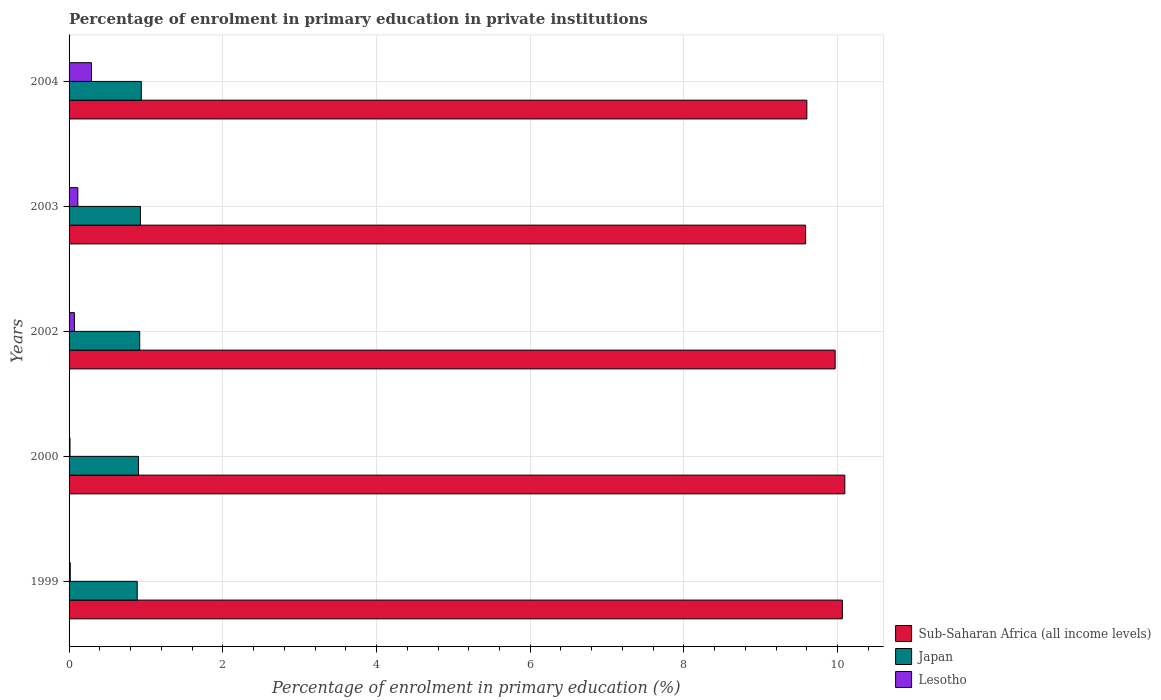How many different coloured bars are there?
Your response must be concise. 3. How many groups of bars are there?
Offer a very short reply. 5. How many bars are there on the 1st tick from the top?
Ensure brevity in your answer.  3. What is the label of the 4th group of bars from the top?
Ensure brevity in your answer.  2000. In how many cases, is the number of bars for a given year not equal to the number of legend labels?
Ensure brevity in your answer.  0. What is the percentage of enrolment in primary education in Sub-Saharan Africa (all income levels) in 1999?
Your answer should be compact. 10.06. Across all years, what is the maximum percentage of enrolment in primary education in Lesotho?
Provide a short and direct response. 0.29. Across all years, what is the minimum percentage of enrolment in primary education in Sub-Saharan Africa (all income levels)?
Offer a very short reply. 9.58. In which year was the percentage of enrolment in primary education in Lesotho maximum?
Your response must be concise. 2004. What is the total percentage of enrolment in primary education in Sub-Saharan Africa (all income levels) in the graph?
Ensure brevity in your answer.  49.3. What is the difference between the percentage of enrolment in primary education in Japan in 2000 and that in 2004?
Provide a succinct answer. -0.04. What is the difference between the percentage of enrolment in primary education in Japan in 2004 and the percentage of enrolment in primary education in Lesotho in 2000?
Keep it short and to the point. 0.93. What is the average percentage of enrolment in primary education in Lesotho per year?
Provide a short and direct response. 0.1. In the year 1999, what is the difference between the percentage of enrolment in primary education in Japan and percentage of enrolment in primary education in Lesotho?
Offer a very short reply. 0.87. What is the ratio of the percentage of enrolment in primary education in Japan in 2000 to that in 2002?
Offer a terse response. 0.98. Is the difference between the percentage of enrolment in primary education in Japan in 2000 and 2003 greater than the difference between the percentage of enrolment in primary education in Lesotho in 2000 and 2003?
Keep it short and to the point. Yes. What is the difference between the highest and the second highest percentage of enrolment in primary education in Sub-Saharan Africa (all income levels)?
Your answer should be compact. 0.03. What is the difference between the highest and the lowest percentage of enrolment in primary education in Sub-Saharan Africa (all income levels)?
Keep it short and to the point. 0.51. In how many years, is the percentage of enrolment in primary education in Japan greater than the average percentage of enrolment in primary education in Japan taken over all years?
Your answer should be compact. 3. Is the sum of the percentage of enrolment in primary education in Japan in 2002 and 2003 greater than the maximum percentage of enrolment in primary education in Sub-Saharan Africa (all income levels) across all years?
Offer a very short reply. No. What does the 1st bar from the bottom in 1999 represents?
Provide a succinct answer. Sub-Saharan Africa (all income levels). Is it the case that in every year, the sum of the percentage of enrolment in primary education in Japan and percentage of enrolment in primary education in Lesotho is greater than the percentage of enrolment in primary education in Sub-Saharan Africa (all income levels)?
Keep it short and to the point. No. How many bars are there?
Keep it short and to the point. 15. What is the difference between two consecutive major ticks on the X-axis?
Make the answer very short. 2. Are the values on the major ticks of X-axis written in scientific E-notation?
Your answer should be very brief. No. Does the graph contain any zero values?
Give a very brief answer. No. Where does the legend appear in the graph?
Your response must be concise. Bottom right. How many legend labels are there?
Offer a very short reply. 3. What is the title of the graph?
Your answer should be very brief. Percentage of enrolment in primary education in private institutions. Does "Micronesia" appear as one of the legend labels in the graph?
Your response must be concise. No. What is the label or title of the X-axis?
Offer a very short reply. Percentage of enrolment in primary education (%). What is the Percentage of enrolment in primary education (%) of Sub-Saharan Africa (all income levels) in 1999?
Your response must be concise. 10.06. What is the Percentage of enrolment in primary education (%) in Japan in 1999?
Ensure brevity in your answer.  0.89. What is the Percentage of enrolment in primary education (%) in Lesotho in 1999?
Provide a succinct answer. 0.02. What is the Percentage of enrolment in primary education (%) of Sub-Saharan Africa (all income levels) in 2000?
Keep it short and to the point. 10.09. What is the Percentage of enrolment in primary education (%) in Japan in 2000?
Your answer should be compact. 0.9. What is the Percentage of enrolment in primary education (%) of Lesotho in 2000?
Keep it short and to the point. 0.01. What is the Percentage of enrolment in primary education (%) in Sub-Saharan Africa (all income levels) in 2002?
Ensure brevity in your answer.  9.97. What is the Percentage of enrolment in primary education (%) in Japan in 2002?
Provide a short and direct response. 0.92. What is the Percentage of enrolment in primary education (%) of Lesotho in 2002?
Give a very brief answer. 0.07. What is the Percentage of enrolment in primary education (%) of Sub-Saharan Africa (all income levels) in 2003?
Your answer should be very brief. 9.58. What is the Percentage of enrolment in primary education (%) in Japan in 2003?
Your answer should be compact. 0.93. What is the Percentage of enrolment in primary education (%) of Lesotho in 2003?
Your answer should be very brief. 0.11. What is the Percentage of enrolment in primary education (%) of Sub-Saharan Africa (all income levels) in 2004?
Provide a succinct answer. 9.6. What is the Percentage of enrolment in primary education (%) in Japan in 2004?
Your response must be concise. 0.94. What is the Percentage of enrolment in primary education (%) in Lesotho in 2004?
Give a very brief answer. 0.29. Across all years, what is the maximum Percentage of enrolment in primary education (%) in Sub-Saharan Africa (all income levels)?
Ensure brevity in your answer.  10.09. Across all years, what is the maximum Percentage of enrolment in primary education (%) in Japan?
Your answer should be compact. 0.94. Across all years, what is the maximum Percentage of enrolment in primary education (%) of Lesotho?
Ensure brevity in your answer.  0.29. Across all years, what is the minimum Percentage of enrolment in primary education (%) of Sub-Saharan Africa (all income levels)?
Your answer should be very brief. 9.58. Across all years, what is the minimum Percentage of enrolment in primary education (%) in Japan?
Provide a short and direct response. 0.89. Across all years, what is the minimum Percentage of enrolment in primary education (%) in Lesotho?
Your answer should be compact. 0.01. What is the total Percentage of enrolment in primary education (%) in Sub-Saharan Africa (all income levels) in the graph?
Your response must be concise. 49.3. What is the total Percentage of enrolment in primary education (%) in Japan in the graph?
Provide a short and direct response. 4.58. What is the total Percentage of enrolment in primary education (%) of Lesotho in the graph?
Offer a terse response. 0.5. What is the difference between the Percentage of enrolment in primary education (%) in Sub-Saharan Africa (all income levels) in 1999 and that in 2000?
Offer a terse response. -0.03. What is the difference between the Percentage of enrolment in primary education (%) in Japan in 1999 and that in 2000?
Offer a very short reply. -0.02. What is the difference between the Percentage of enrolment in primary education (%) in Lesotho in 1999 and that in 2000?
Provide a short and direct response. 0. What is the difference between the Percentage of enrolment in primary education (%) in Sub-Saharan Africa (all income levels) in 1999 and that in 2002?
Offer a terse response. 0.09. What is the difference between the Percentage of enrolment in primary education (%) in Japan in 1999 and that in 2002?
Provide a short and direct response. -0.03. What is the difference between the Percentage of enrolment in primary education (%) in Lesotho in 1999 and that in 2002?
Make the answer very short. -0.05. What is the difference between the Percentage of enrolment in primary education (%) in Sub-Saharan Africa (all income levels) in 1999 and that in 2003?
Offer a terse response. 0.48. What is the difference between the Percentage of enrolment in primary education (%) in Japan in 1999 and that in 2003?
Offer a terse response. -0.04. What is the difference between the Percentage of enrolment in primary education (%) of Lesotho in 1999 and that in 2003?
Provide a succinct answer. -0.1. What is the difference between the Percentage of enrolment in primary education (%) of Sub-Saharan Africa (all income levels) in 1999 and that in 2004?
Ensure brevity in your answer.  0.46. What is the difference between the Percentage of enrolment in primary education (%) in Japan in 1999 and that in 2004?
Keep it short and to the point. -0.05. What is the difference between the Percentage of enrolment in primary education (%) in Lesotho in 1999 and that in 2004?
Provide a succinct answer. -0.28. What is the difference between the Percentage of enrolment in primary education (%) of Sub-Saharan Africa (all income levels) in 2000 and that in 2002?
Give a very brief answer. 0.13. What is the difference between the Percentage of enrolment in primary education (%) in Japan in 2000 and that in 2002?
Provide a short and direct response. -0.02. What is the difference between the Percentage of enrolment in primary education (%) in Lesotho in 2000 and that in 2002?
Your response must be concise. -0.06. What is the difference between the Percentage of enrolment in primary education (%) in Sub-Saharan Africa (all income levels) in 2000 and that in 2003?
Your answer should be compact. 0.51. What is the difference between the Percentage of enrolment in primary education (%) in Japan in 2000 and that in 2003?
Your response must be concise. -0.02. What is the difference between the Percentage of enrolment in primary education (%) of Lesotho in 2000 and that in 2003?
Keep it short and to the point. -0.1. What is the difference between the Percentage of enrolment in primary education (%) of Sub-Saharan Africa (all income levels) in 2000 and that in 2004?
Provide a succinct answer. 0.49. What is the difference between the Percentage of enrolment in primary education (%) of Japan in 2000 and that in 2004?
Offer a terse response. -0.04. What is the difference between the Percentage of enrolment in primary education (%) of Lesotho in 2000 and that in 2004?
Your answer should be very brief. -0.28. What is the difference between the Percentage of enrolment in primary education (%) in Sub-Saharan Africa (all income levels) in 2002 and that in 2003?
Give a very brief answer. 0.38. What is the difference between the Percentage of enrolment in primary education (%) in Japan in 2002 and that in 2003?
Provide a short and direct response. -0.01. What is the difference between the Percentage of enrolment in primary education (%) in Lesotho in 2002 and that in 2003?
Keep it short and to the point. -0.04. What is the difference between the Percentage of enrolment in primary education (%) in Sub-Saharan Africa (all income levels) in 2002 and that in 2004?
Make the answer very short. 0.37. What is the difference between the Percentage of enrolment in primary education (%) in Japan in 2002 and that in 2004?
Ensure brevity in your answer.  -0.02. What is the difference between the Percentage of enrolment in primary education (%) of Lesotho in 2002 and that in 2004?
Your answer should be compact. -0.22. What is the difference between the Percentage of enrolment in primary education (%) in Sub-Saharan Africa (all income levels) in 2003 and that in 2004?
Make the answer very short. -0.02. What is the difference between the Percentage of enrolment in primary education (%) of Japan in 2003 and that in 2004?
Offer a very short reply. -0.01. What is the difference between the Percentage of enrolment in primary education (%) of Lesotho in 2003 and that in 2004?
Keep it short and to the point. -0.18. What is the difference between the Percentage of enrolment in primary education (%) in Sub-Saharan Africa (all income levels) in 1999 and the Percentage of enrolment in primary education (%) in Japan in 2000?
Keep it short and to the point. 9.16. What is the difference between the Percentage of enrolment in primary education (%) of Sub-Saharan Africa (all income levels) in 1999 and the Percentage of enrolment in primary education (%) of Lesotho in 2000?
Keep it short and to the point. 10.05. What is the difference between the Percentage of enrolment in primary education (%) of Japan in 1999 and the Percentage of enrolment in primary education (%) of Lesotho in 2000?
Your answer should be compact. 0.87. What is the difference between the Percentage of enrolment in primary education (%) in Sub-Saharan Africa (all income levels) in 1999 and the Percentage of enrolment in primary education (%) in Japan in 2002?
Your answer should be very brief. 9.14. What is the difference between the Percentage of enrolment in primary education (%) of Sub-Saharan Africa (all income levels) in 1999 and the Percentage of enrolment in primary education (%) of Lesotho in 2002?
Give a very brief answer. 9.99. What is the difference between the Percentage of enrolment in primary education (%) of Japan in 1999 and the Percentage of enrolment in primary education (%) of Lesotho in 2002?
Offer a very short reply. 0.82. What is the difference between the Percentage of enrolment in primary education (%) in Sub-Saharan Africa (all income levels) in 1999 and the Percentage of enrolment in primary education (%) in Japan in 2003?
Ensure brevity in your answer.  9.13. What is the difference between the Percentage of enrolment in primary education (%) of Sub-Saharan Africa (all income levels) in 1999 and the Percentage of enrolment in primary education (%) of Lesotho in 2003?
Make the answer very short. 9.95. What is the difference between the Percentage of enrolment in primary education (%) of Japan in 1999 and the Percentage of enrolment in primary education (%) of Lesotho in 2003?
Provide a short and direct response. 0.77. What is the difference between the Percentage of enrolment in primary education (%) of Sub-Saharan Africa (all income levels) in 1999 and the Percentage of enrolment in primary education (%) of Japan in 2004?
Ensure brevity in your answer.  9.12. What is the difference between the Percentage of enrolment in primary education (%) of Sub-Saharan Africa (all income levels) in 1999 and the Percentage of enrolment in primary education (%) of Lesotho in 2004?
Make the answer very short. 9.77. What is the difference between the Percentage of enrolment in primary education (%) in Japan in 1999 and the Percentage of enrolment in primary education (%) in Lesotho in 2004?
Give a very brief answer. 0.6. What is the difference between the Percentage of enrolment in primary education (%) in Sub-Saharan Africa (all income levels) in 2000 and the Percentage of enrolment in primary education (%) in Japan in 2002?
Offer a terse response. 9.17. What is the difference between the Percentage of enrolment in primary education (%) of Sub-Saharan Africa (all income levels) in 2000 and the Percentage of enrolment in primary education (%) of Lesotho in 2002?
Offer a terse response. 10.02. What is the difference between the Percentage of enrolment in primary education (%) in Japan in 2000 and the Percentage of enrolment in primary education (%) in Lesotho in 2002?
Your response must be concise. 0.83. What is the difference between the Percentage of enrolment in primary education (%) in Sub-Saharan Africa (all income levels) in 2000 and the Percentage of enrolment in primary education (%) in Japan in 2003?
Your answer should be compact. 9.16. What is the difference between the Percentage of enrolment in primary education (%) of Sub-Saharan Africa (all income levels) in 2000 and the Percentage of enrolment in primary education (%) of Lesotho in 2003?
Provide a succinct answer. 9.98. What is the difference between the Percentage of enrolment in primary education (%) in Japan in 2000 and the Percentage of enrolment in primary education (%) in Lesotho in 2003?
Ensure brevity in your answer.  0.79. What is the difference between the Percentage of enrolment in primary education (%) in Sub-Saharan Africa (all income levels) in 2000 and the Percentage of enrolment in primary education (%) in Japan in 2004?
Give a very brief answer. 9.15. What is the difference between the Percentage of enrolment in primary education (%) of Sub-Saharan Africa (all income levels) in 2000 and the Percentage of enrolment in primary education (%) of Lesotho in 2004?
Your answer should be very brief. 9.8. What is the difference between the Percentage of enrolment in primary education (%) of Japan in 2000 and the Percentage of enrolment in primary education (%) of Lesotho in 2004?
Your answer should be compact. 0.61. What is the difference between the Percentage of enrolment in primary education (%) in Sub-Saharan Africa (all income levels) in 2002 and the Percentage of enrolment in primary education (%) in Japan in 2003?
Make the answer very short. 9.04. What is the difference between the Percentage of enrolment in primary education (%) in Sub-Saharan Africa (all income levels) in 2002 and the Percentage of enrolment in primary education (%) in Lesotho in 2003?
Keep it short and to the point. 9.85. What is the difference between the Percentage of enrolment in primary education (%) of Japan in 2002 and the Percentage of enrolment in primary education (%) of Lesotho in 2003?
Offer a terse response. 0.81. What is the difference between the Percentage of enrolment in primary education (%) in Sub-Saharan Africa (all income levels) in 2002 and the Percentage of enrolment in primary education (%) in Japan in 2004?
Provide a short and direct response. 9.03. What is the difference between the Percentage of enrolment in primary education (%) in Sub-Saharan Africa (all income levels) in 2002 and the Percentage of enrolment in primary education (%) in Lesotho in 2004?
Offer a very short reply. 9.68. What is the difference between the Percentage of enrolment in primary education (%) of Japan in 2002 and the Percentage of enrolment in primary education (%) of Lesotho in 2004?
Provide a succinct answer. 0.63. What is the difference between the Percentage of enrolment in primary education (%) in Sub-Saharan Africa (all income levels) in 2003 and the Percentage of enrolment in primary education (%) in Japan in 2004?
Ensure brevity in your answer.  8.64. What is the difference between the Percentage of enrolment in primary education (%) in Sub-Saharan Africa (all income levels) in 2003 and the Percentage of enrolment in primary education (%) in Lesotho in 2004?
Provide a short and direct response. 9.29. What is the difference between the Percentage of enrolment in primary education (%) in Japan in 2003 and the Percentage of enrolment in primary education (%) in Lesotho in 2004?
Provide a short and direct response. 0.64. What is the average Percentage of enrolment in primary education (%) of Sub-Saharan Africa (all income levels) per year?
Keep it short and to the point. 9.86. What is the average Percentage of enrolment in primary education (%) in Japan per year?
Your answer should be compact. 0.92. What is the average Percentage of enrolment in primary education (%) of Lesotho per year?
Your response must be concise. 0.1. In the year 1999, what is the difference between the Percentage of enrolment in primary education (%) of Sub-Saharan Africa (all income levels) and Percentage of enrolment in primary education (%) of Japan?
Provide a short and direct response. 9.17. In the year 1999, what is the difference between the Percentage of enrolment in primary education (%) of Sub-Saharan Africa (all income levels) and Percentage of enrolment in primary education (%) of Lesotho?
Your answer should be very brief. 10.05. In the year 1999, what is the difference between the Percentage of enrolment in primary education (%) in Japan and Percentage of enrolment in primary education (%) in Lesotho?
Your answer should be very brief. 0.87. In the year 2000, what is the difference between the Percentage of enrolment in primary education (%) of Sub-Saharan Africa (all income levels) and Percentage of enrolment in primary education (%) of Japan?
Offer a very short reply. 9.19. In the year 2000, what is the difference between the Percentage of enrolment in primary education (%) in Sub-Saharan Africa (all income levels) and Percentage of enrolment in primary education (%) in Lesotho?
Ensure brevity in your answer.  10.08. In the year 2000, what is the difference between the Percentage of enrolment in primary education (%) of Japan and Percentage of enrolment in primary education (%) of Lesotho?
Provide a short and direct response. 0.89. In the year 2002, what is the difference between the Percentage of enrolment in primary education (%) in Sub-Saharan Africa (all income levels) and Percentage of enrolment in primary education (%) in Japan?
Provide a succinct answer. 9.05. In the year 2002, what is the difference between the Percentage of enrolment in primary education (%) of Sub-Saharan Africa (all income levels) and Percentage of enrolment in primary education (%) of Lesotho?
Provide a short and direct response. 9.9. In the year 2002, what is the difference between the Percentage of enrolment in primary education (%) of Japan and Percentage of enrolment in primary education (%) of Lesotho?
Your answer should be compact. 0.85. In the year 2003, what is the difference between the Percentage of enrolment in primary education (%) in Sub-Saharan Africa (all income levels) and Percentage of enrolment in primary education (%) in Japan?
Give a very brief answer. 8.65. In the year 2003, what is the difference between the Percentage of enrolment in primary education (%) in Sub-Saharan Africa (all income levels) and Percentage of enrolment in primary education (%) in Lesotho?
Your answer should be compact. 9.47. In the year 2003, what is the difference between the Percentage of enrolment in primary education (%) of Japan and Percentage of enrolment in primary education (%) of Lesotho?
Offer a terse response. 0.81. In the year 2004, what is the difference between the Percentage of enrolment in primary education (%) in Sub-Saharan Africa (all income levels) and Percentage of enrolment in primary education (%) in Japan?
Your answer should be compact. 8.66. In the year 2004, what is the difference between the Percentage of enrolment in primary education (%) in Sub-Saharan Africa (all income levels) and Percentage of enrolment in primary education (%) in Lesotho?
Provide a succinct answer. 9.31. In the year 2004, what is the difference between the Percentage of enrolment in primary education (%) of Japan and Percentage of enrolment in primary education (%) of Lesotho?
Give a very brief answer. 0.65. What is the ratio of the Percentage of enrolment in primary education (%) in Sub-Saharan Africa (all income levels) in 1999 to that in 2000?
Offer a very short reply. 1. What is the ratio of the Percentage of enrolment in primary education (%) of Lesotho in 1999 to that in 2000?
Give a very brief answer. 1.28. What is the ratio of the Percentage of enrolment in primary education (%) in Sub-Saharan Africa (all income levels) in 1999 to that in 2002?
Give a very brief answer. 1.01. What is the ratio of the Percentage of enrolment in primary education (%) of Japan in 1999 to that in 2002?
Make the answer very short. 0.96. What is the ratio of the Percentage of enrolment in primary education (%) in Lesotho in 1999 to that in 2002?
Your answer should be very brief. 0.22. What is the ratio of the Percentage of enrolment in primary education (%) in Sub-Saharan Africa (all income levels) in 1999 to that in 2003?
Ensure brevity in your answer.  1.05. What is the ratio of the Percentage of enrolment in primary education (%) in Japan in 1999 to that in 2003?
Keep it short and to the point. 0.95. What is the ratio of the Percentage of enrolment in primary education (%) of Lesotho in 1999 to that in 2003?
Provide a short and direct response. 0.14. What is the ratio of the Percentage of enrolment in primary education (%) of Sub-Saharan Africa (all income levels) in 1999 to that in 2004?
Your response must be concise. 1.05. What is the ratio of the Percentage of enrolment in primary education (%) in Japan in 1999 to that in 2004?
Your response must be concise. 0.94. What is the ratio of the Percentage of enrolment in primary education (%) in Lesotho in 1999 to that in 2004?
Your response must be concise. 0.05. What is the ratio of the Percentage of enrolment in primary education (%) of Sub-Saharan Africa (all income levels) in 2000 to that in 2002?
Provide a short and direct response. 1.01. What is the ratio of the Percentage of enrolment in primary education (%) in Japan in 2000 to that in 2002?
Your answer should be very brief. 0.98. What is the ratio of the Percentage of enrolment in primary education (%) of Lesotho in 2000 to that in 2002?
Your answer should be compact. 0.17. What is the ratio of the Percentage of enrolment in primary education (%) in Sub-Saharan Africa (all income levels) in 2000 to that in 2003?
Keep it short and to the point. 1.05. What is the ratio of the Percentage of enrolment in primary education (%) in Japan in 2000 to that in 2003?
Keep it short and to the point. 0.97. What is the ratio of the Percentage of enrolment in primary education (%) in Lesotho in 2000 to that in 2003?
Make the answer very short. 0.11. What is the ratio of the Percentage of enrolment in primary education (%) of Sub-Saharan Africa (all income levels) in 2000 to that in 2004?
Provide a succinct answer. 1.05. What is the ratio of the Percentage of enrolment in primary education (%) of Japan in 2000 to that in 2004?
Provide a succinct answer. 0.96. What is the ratio of the Percentage of enrolment in primary education (%) in Lesotho in 2000 to that in 2004?
Your answer should be compact. 0.04. What is the ratio of the Percentage of enrolment in primary education (%) in Sub-Saharan Africa (all income levels) in 2002 to that in 2003?
Offer a very short reply. 1.04. What is the ratio of the Percentage of enrolment in primary education (%) in Japan in 2002 to that in 2003?
Offer a very short reply. 0.99. What is the ratio of the Percentage of enrolment in primary education (%) in Lesotho in 2002 to that in 2003?
Keep it short and to the point. 0.61. What is the ratio of the Percentage of enrolment in primary education (%) in Sub-Saharan Africa (all income levels) in 2002 to that in 2004?
Your response must be concise. 1.04. What is the ratio of the Percentage of enrolment in primary education (%) of Japan in 2002 to that in 2004?
Make the answer very short. 0.98. What is the ratio of the Percentage of enrolment in primary education (%) in Lesotho in 2002 to that in 2004?
Make the answer very short. 0.24. What is the ratio of the Percentage of enrolment in primary education (%) of Japan in 2003 to that in 2004?
Give a very brief answer. 0.99. What is the ratio of the Percentage of enrolment in primary education (%) in Lesotho in 2003 to that in 2004?
Provide a short and direct response. 0.39. What is the difference between the highest and the second highest Percentage of enrolment in primary education (%) of Sub-Saharan Africa (all income levels)?
Make the answer very short. 0.03. What is the difference between the highest and the second highest Percentage of enrolment in primary education (%) of Japan?
Your response must be concise. 0.01. What is the difference between the highest and the second highest Percentage of enrolment in primary education (%) of Lesotho?
Your response must be concise. 0.18. What is the difference between the highest and the lowest Percentage of enrolment in primary education (%) in Sub-Saharan Africa (all income levels)?
Offer a very short reply. 0.51. What is the difference between the highest and the lowest Percentage of enrolment in primary education (%) of Japan?
Keep it short and to the point. 0.05. What is the difference between the highest and the lowest Percentage of enrolment in primary education (%) in Lesotho?
Keep it short and to the point. 0.28. 